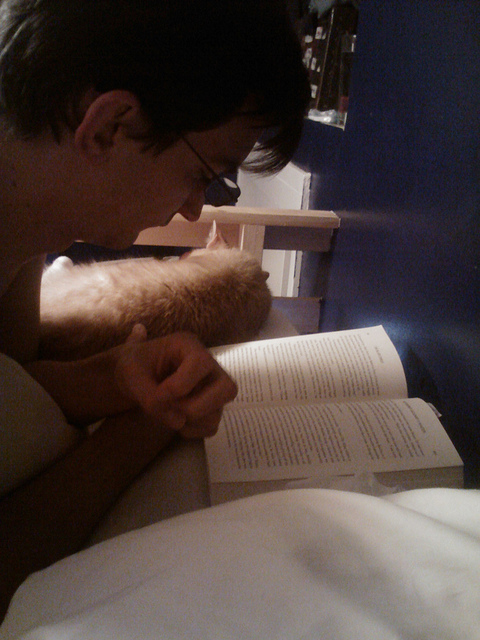<image>What is the symbol the cat is sleeping in front of? I am unsure about the symbol the cat is sleeping in front of. It could possibly be a cross or a 't'. What is the symbol the cat is sleeping in front of? The symbol the cat is sleeping in front of is unknown. 